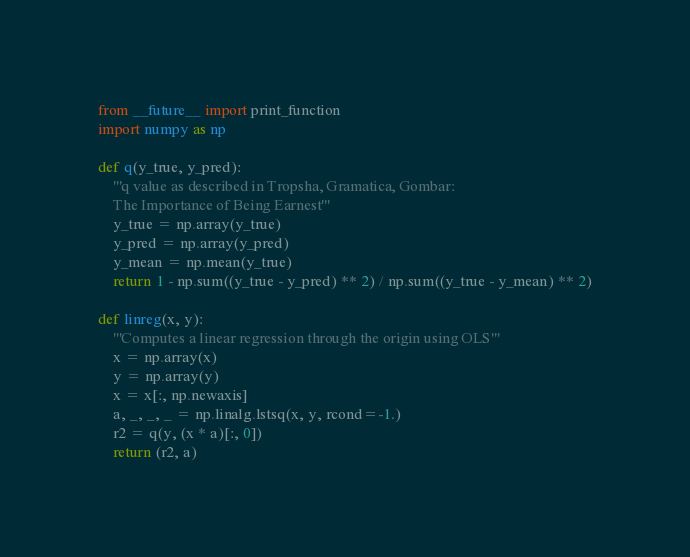<code> <loc_0><loc_0><loc_500><loc_500><_Python_>from __future__ import print_function
import numpy as np

def q(y_true, y_pred):
	'''q value as described in Tropsha, Gramatica, Gombar:
	The Importance of Being Earnest'''
	y_true = np.array(y_true)
	y_pred = np.array(y_pred)
	y_mean = np.mean(y_true)
	return 1 - np.sum((y_true - y_pred) ** 2) / np.sum((y_true - y_mean) ** 2)

def linreg(x, y):
	'''Computes a linear regression through the origin using OLS'''
	x = np.array(x)
	y = np.array(y)
	x = x[:, np.newaxis]
	a, _, _, _ = np.linalg.lstsq(x, y, rcond=-1.)
	r2 = q(y, (x * a)[:, 0])
	return (r2, a)</code> 